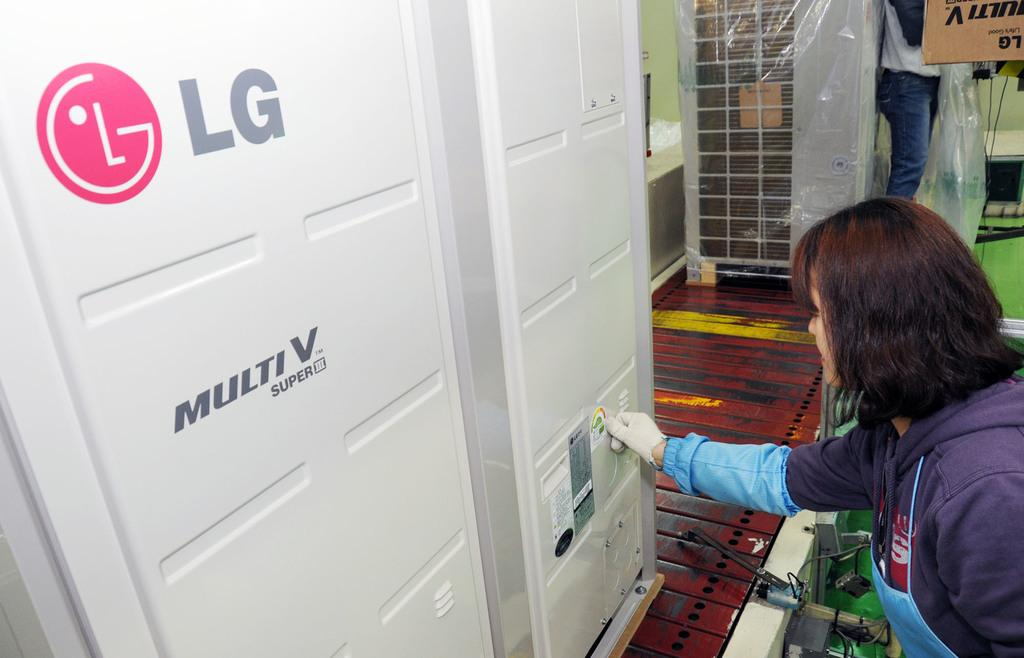<image>
Share a concise interpretation of the image provided. A product from the company LG called Multi V Super 